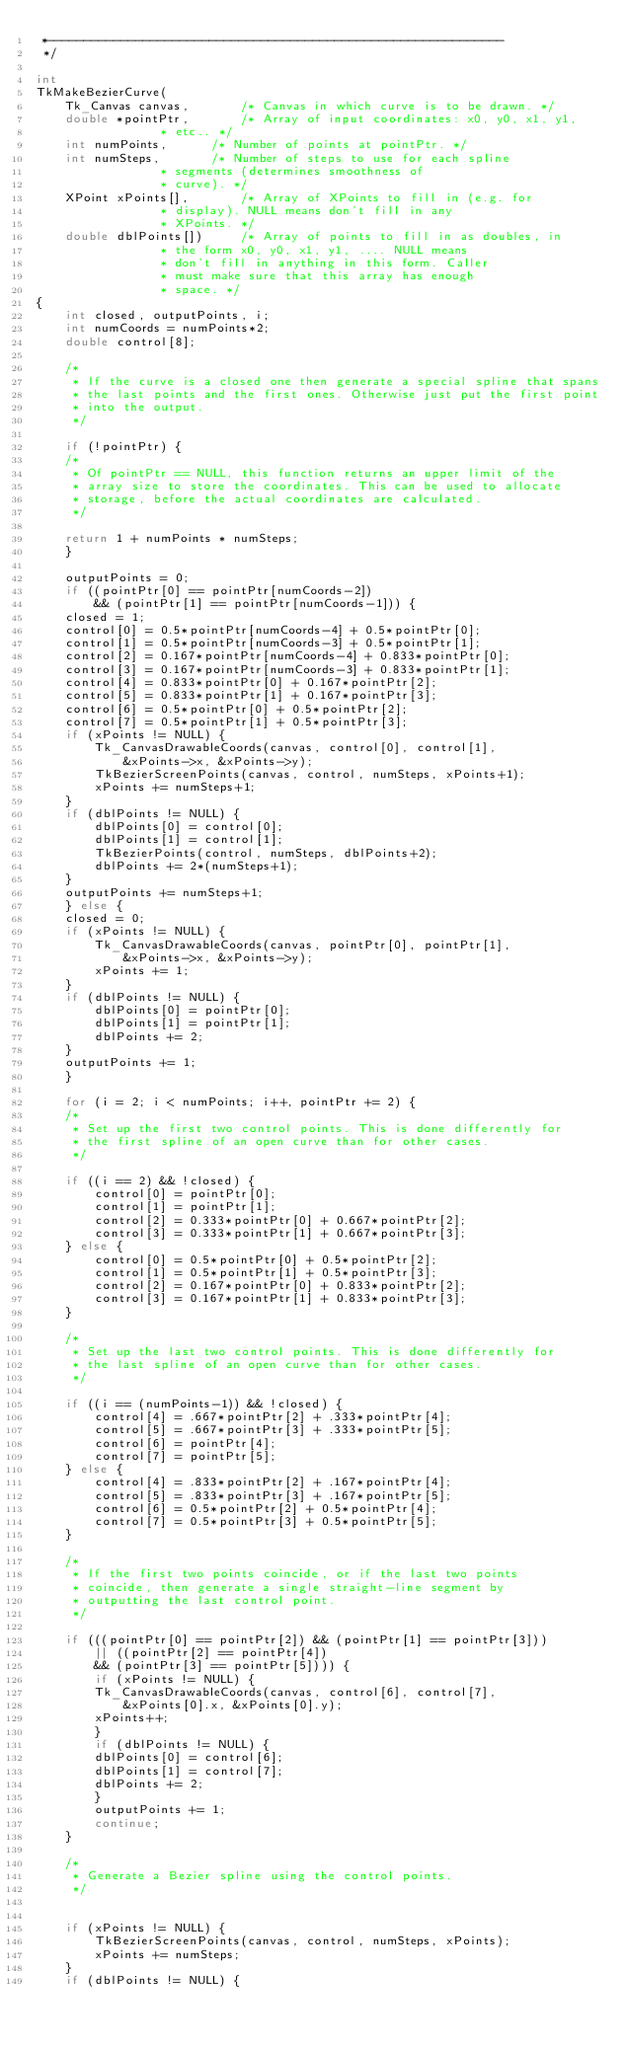<code> <loc_0><loc_0><loc_500><loc_500><_C_> *--------------------------------------------------------------
 */

int
TkMakeBezierCurve(
    Tk_Canvas canvas,		/* Canvas in which curve is to be drawn. */
    double *pointPtr,		/* Array of input coordinates: x0, y0, x1, y1,
				 * etc.. */
    int numPoints,		/* Number of points at pointPtr. */
    int numSteps,		/* Number of steps to use for each spline
				 * segments (determines smoothness of
				 * curve). */
    XPoint xPoints[],		/* Array of XPoints to fill in (e.g. for
				 * display). NULL means don't fill in any
				 * XPoints. */
    double dblPoints[])		/* Array of points to fill in as doubles, in
				 * the form x0, y0, x1, y1, .... NULL means
				 * don't fill in anything in this form. Caller
				 * must make sure that this array has enough
				 * space. */
{
    int closed, outputPoints, i;
    int numCoords = numPoints*2;
    double control[8];

    /*
     * If the curve is a closed one then generate a special spline that spans
     * the last points and the first ones. Otherwise just put the first point
     * into the output.
     */

    if (!pointPtr) {
	/*
	 * Of pointPtr == NULL, this function returns an upper limit of the
	 * array size to store the coordinates. This can be used to allocate
	 * storage, before the actual coordinates are calculated.
	 */

	return 1 + numPoints * numSteps;
    }

    outputPoints = 0;
    if ((pointPtr[0] == pointPtr[numCoords-2])
	    && (pointPtr[1] == pointPtr[numCoords-1])) {
	closed = 1;
	control[0] = 0.5*pointPtr[numCoords-4] + 0.5*pointPtr[0];
	control[1] = 0.5*pointPtr[numCoords-3] + 0.5*pointPtr[1];
	control[2] = 0.167*pointPtr[numCoords-4] + 0.833*pointPtr[0];
	control[3] = 0.167*pointPtr[numCoords-3] + 0.833*pointPtr[1];
	control[4] = 0.833*pointPtr[0] + 0.167*pointPtr[2];
	control[5] = 0.833*pointPtr[1] + 0.167*pointPtr[3];
	control[6] = 0.5*pointPtr[0] + 0.5*pointPtr[2];
	control[7] = 0.5*pointPtr[1] + 0.5*pointPtr[3];
	if (xPoints != NULL) {
	    Tk_CanvasDrawableCoords(canvas, control[0], control[1],
		    &xPoints->x, &xPoints->y);
	    TkBezierScreenPoints(canvas, control, numSteps, xPoints+1);
	    xPoints += numSteps+1;
	}
	if (dblPoints != NULL) {
	    dblPoints[0] = control[0];
	    dblPoints[1] = control[1];
	    TkBezierPoints(control, numSteps, dblPoints+2);
	    dblPoints += 2*(numSteps+1);
	}
	outputPoints += numSteps+1;
    } else {
	closed = 0;
	if (xPoints != NULL) {
	    Tk_CanvasDrawableCoords(canvas, pointPtr[0], pointPtr[1],
		    &xPoints->x, &xPoints->y);
	    xPoints += 1;
	}
	if (dblPoints != NULL) {
	    dblPoints[0] = pointPtr[0];
	    dblPoints[1] = pointPtr[1];
	    dblPoints += 2;
	}
	outputPoints += 1;
    }

    for (i = 2; i < numPoints; i++, pointPtr += 2) {
	/*
	 * Set up the first two control points. This is done differently for
	 * the first spline of an open curve than for other cases.
	 */

	if ((i == 2) && !closed) {
	    control[0] = pointPtr[0];
	    control[1] = pointPtr[1];
	    control[2] = 0.333*pointPtr[0] + 0.667*pointPtr[2];
	    control[3] = 0.333*pointPtr[1] + 0.667*pointPtr[3];
	} else {
	    control[0] = 0.5*pointPtr[0] + 0.5*pointPtr[2];
	    control[1] = 0.5*pointPtr[1] + 0.5*pointPtr[3];
	    control[2] = 0.167*pointPtr[0] + 0.833*pointPtr[2];
	    control[3] = 0.167*pointPtr[1] + 0.833*pointPtr[3];
	}

	/*
	 * Set up the last two control points. This is done differently for
	 * the last spline of an open curve than for other cases.
	 */

	if ((i == (numPoints-1)) && !closed) {
	    control[4] = .667*pointPtr[2] + .333*pointPtr[4];
	    control[5] = .667*pointPtr[3] + .333*pointPtr[5];
	    control[6] = pointPtr[4];
	    control[7] = pointPtr[5];
	} else {
	    control[4] = .833*pointPtr[2] + .167*pointPtr[4];
	    control[5] = .833*pointPtr[3] + .167*pointPtr[5];
	    control[6] = 0.5*pointPtr[2] + 0.5*pointPtr[4];
	    control[7] = 0.5*pointPtr[3] + 0.5*pointPtr[5];
	}

	/*
	 * If the first two points coincide, or if the last two points
	 * coincide, then generate a single straight-line segment by
	 * outputting the last control point.
	 */

	if (((pointPtr[0] == pointPtr[2]) && (pointPtr[1] == pointPtr[3]))
		|| ((pointPtr[2] == pointPtr[4])
		&& (pointPtr[3] == pointPtr[5]))) {
	    if (xPoints != NULL) {
		Tk_CanvasDrawableCoords(canvas, control[6], control[7],
			&xPoints[0].x, &xPoints[0].y);
		xPoints++;
	    }
	    if (dblPoints != NULL) {
		dblPoints[0] = control[6];
		dblPoints[1] = control[7];
		dblPoints += 2;
	    }
	    outputPoints += 1;
	    continue;
	}

	/*
	 * Generate a Bezier spline using the control points.
	 */


	if (xPoints != NULL) {
	    TkBezierScreenPoints(canvas, control, numSteps, xPoints);
	    xPoints += numSteps;
	}
	if (dblPoints != NULL) {</code> 